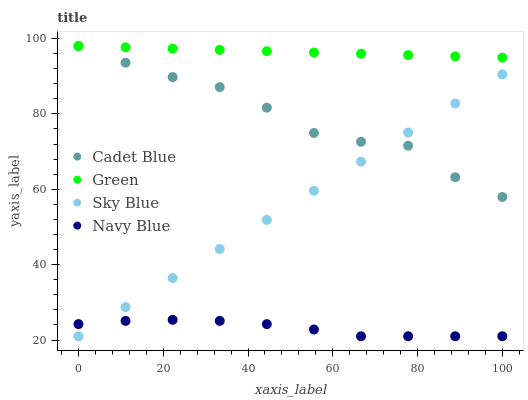Does Navy Blue have the minimum area under the curve?
Answer yes or no. Yes. Does Green have the maximum area under the curve?
Answer yes or no. Yes. Does Cadet Blue have the minimum area under the curve?
Answer yes or no. No. Does Cadet Blue have the maximum area under the curve?
Answer yes or no. No. Is Sky Blue the smoothest?
Answer yes or no. Yes. Is Cadet Blue the roughest?
Answer yes or no. Yes. Is Green the smoothest?
Answer yes or no. No. Is Green the roughest?
Answer yes or no. No. Does Sky Blue have the lowest value?
Answer yes or no. Yes. Does Cadet Blue have the lowest value?
Answer yes or no. No. Does Green have the highest value?
Answer yes or no. Yes. Does Navy Blue have the highest value?
Answer yes or no. No. Is Sky Blue less than Green?
Answer yes or no. Yes. Is Cadet Blue greater than Navy Blue?
Answer yes or no. Yes. Does Cadet Blue intersect Green?
Answer yes or no. Yes. Is Cadet Blue less than Green?
Answer yes or no. No. Is Cadet Blue greater than Green?
Answer yes or no. No. Does Sky Blue intersect Green?
Answer yes or no. No. 